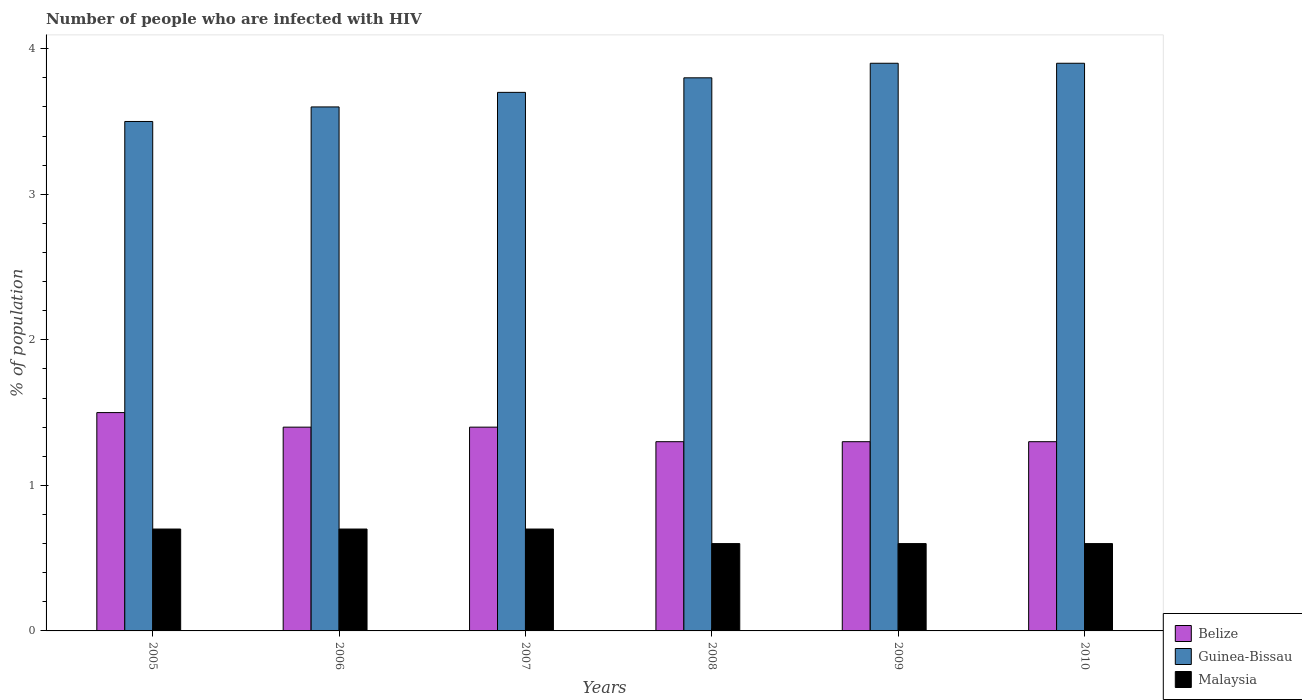How many groups of bars are there?
Provide a short and direct response. 6. Are the number of bars on each tick of the X-axis equal?
Give a very brief answer. Yes. How many bars are there on the 5th tick from the left?
Your response must be concise. 3. In how many cases, is the number of bars for a given year not equal to the number of legend labels?
Give a very brief answer. 0. What is the percentage of HIV infected population in in Belize in 2008?
Give a very brief answer. 1.3. Across all years, what is the maximum percentage of HIV infected population in in Guinea-Bissau?
Keep it short and to the point. 3.9. Across all years, what is the minimum percentage of HIV infected population in in Malaysia?
Your answer should be very brief. 0.6. What is the difference between the percentage of HIV infected population in in Malaysia in 2005 and that in 2007?
Provide a succinct answer. 0. What is the average percentage of HIV infected population in in Malaysia per year?
Provide a succinct answer. 0.65. In how many years, is the percentage of HIV infected population in in Belize greater than 0.4 %?
Offer a terse response. 6. What is the ratio of the percentage of HIV infected population in in Malaysia in 2007 to that in 2008?
Your response must be concise. 1.17. What is the difference between the highest and the lowest percentage of HIV infected population in in Belize?
Provide a succinct answer. 0.2. In how many years, is the percentage of HIV infected population in in Malaysia greater than the average percentage of HIV infected population in in Malaysia taken over all years?
Keep it short and to the point. 3. Is the sum of the percentage of HIV infected population in in Belize in 2006 and 2007 greater than the maximum percentage of HIV infected population in in Malaysia across all years?
Ensure brevity in your answer.  Yes. What does the 2nd bar from the left in 2007 represents?
Your response must be concise. Guinea-Bissau. What does the 1st bar from the right in 2010 represents?
Ensure brevity in your answer.  Malaysia. How many bars are there?
Your answer should be compact. 18. Where does the legend appear in the graph?
Your response must be concise. Bottom right. How are the legend labels stacked?
Keep it short and to the point. Vertical. What is the title of the graph?
Your answer should be very brief. Number of people who are infected with HIV. Does "Finland" appear as one of the legend labels in the graph?
Your answer should be compact. No. What is the label or title of the Y-axis?
Ensure brevity in your answer.  % of population. What is the % of population of Guinea-Bissau in 2006?
Keep it short and to the point. 3.6. What is the % of population of Malaysia in 2007?
Offer a very short reply. 0.7. What is the % of population of Guinea-Bissau in 2008?
Offer a terse response. 3.8. What is the % of population of Malaysia in 2008?
Your answer should be very brief. 0.6. What is the % of population of Belize in 2009?
Your answer should be compact. 1.3. What is the % of population of Guinea-Bissau in 2009?
Offer a very short reply. 3.9. What is the % of population in Belize in 2010?
Make the answer very short. 1.3. Across all years, what is the maximum % of population in Malaysia?
Give a very brief answer. 0.7. Across all years, what is the minimum % of population in Belize?
Your answer should be compact. 1.3. Across all years, what is the minimum % of population in Malaysia?
Offer a very short reply. 0.6. What is the total % of population of Belize in the graph?
Give a very brief answer. 8.2. What is the total % of population in Guinea-Bissau in the graph?
Offer a very short reply. 22.4. What is the difference between the % of population in Belize in 2005 and that in 2006?
Make the answer very short. 0.1. What is the difference between the % of population in Belize in 2005 and that in 2008?
Keep it short and to the point. 0.2. What is the difference between the % of population in Guinea-Bissau in 2005 and that in 2008?
Ensure brevity in your answer.  -0.3. What is the difference between the % of population in Belize in 2005 and that in 2009?
Make the answer very short. 0.2. What is the difference between the % of population in Belize in 2005 and that in 2010?
Your answer should be very brief. 0.2. What is the difference between the % of population of Guinea-Bissau in 2005 and that in 2010?
Your response must be concise. -0.4. What is the difference between the % of population in Malaysia in 2005 and that in 2010?
Offer a very short reply. 0.1. What is the difference between the % of population of Belize in 2006 and that in 2007?
Keep it short and to the point. 0. What is the difference between the % of population of Malaysia in 2006 and that in 2007?
Make the answer very short. 0. What is the difference between the % of population in Guinea-Bissau in 2006 and that in 2008?
Your response must be concise. -0.2. What is the difference between the % of population of Malaysia in 2006 and that in 2008?
Provide a short and direct response. 0.1. What is the difference between the % of population in Guinea-Bissau in 2006 and that in 2009?
Provide a short and direct response. -0.3. What is the difference between the % of population in Malaysia in 2006 and that in 2010?
Your answer should be very brief. 0.1. What is the difference between the % of population of Malaysia in 2007 and that in 2008?
Provide a short and direct response. 0.1. What is the difference between the % of population in Belize in 2007 and that in 2010?
Keep it short and to the point. 0.1. What is the difference between the % of population in Belize in 2008 and that in 2009?
Offer a very short reply. 0. What is the difference between the % of population of Malaysia in 2008 and that in 2009?
Offer a very short reply. 0. What is the difference between the % of population in Belize in 2008 and that in 2010?
Offer a terse response. 0. What is the difference between the % of population of Belize in 2009 and that in 2010?
Provide a short and direct response. 0. What is the difference between the % of population in Guinea-Bissau in 2009 and that in 2010?
Offer a terse response. 0. What is the difference between the % of population of Belize in 2005 and the % of population of Guinea-Bissau in 2006?
Your response must be concise. -2.1. What is the difference between the % of population in Guinea-Bissau in 2005 and the % of population in Malaysia in 2006?
Your answer should be compact. 2.8. What is the difference between the % of population in Belize in 2005 and the % of population in Malaysia in 2007?
Offer a terse response. 0.8. What is the difference between the % of population in Belize in 2005 and the % of population in Malaysia in 2008?
Your response must be concise. 0.9. What is the difference between the % of population of Guinea-Bissau in 2005 and the % of population of Malaysia in 2008?
Provide a succinct answer. 2.9. What is the difference between the % of population in Belize in 2005 and the % of population in Guinea-Bissau in 2009?
Ensure brevity in your answer.  -2.4. What is the difference between the % of population in Belize in 2005 and the % of population in Malaysia in 2009?
Provide a short and direct response. 0.9. What is the difference between the % of population of Belize in 2005 and the % of population of Guinea-Bissau in 2010?
Ensure brevity in your answer.  -2.4. What is the difference between the % of population in Belize in 2006 and the % of population in Guinea-Bissau in 2007?
Your answer should be very brief. -2.3. What is the difference between the % of population in Belize in 2006 and the % of population in Guinea-Bissau in 2008?
Provide a short and direct response. -2.4. What is the difference between the % of population in Belize in 2006 and the % of population in Malaysia in 2008?
Your answer should be very brief. 0.8. What is the difference between the % of population of Belize in 2006 and the % of population of Guinea-Bissau in 2009?
Provide a short and direct response. -2.5. What is the difference between the % of population of Belize in 2007 and the % of population of Malaysia in 2008?
Your answer should be compact. 0.8. What is the difference between the % of population in Guinea-Bissau in 2007 and the % of population in Malaysia in 2009?
Your answer should be very brief. 3.1. What is the difference between the % of population of Belize in 2007 and the % of population of Malaysia in 2010?
Your response must be concise. 0.8. What is the difference between the % of population of Guinea-Bissau in 2008 and the % of population of Malaysia in 2009?
Give a very brief answer. 3.2. What is the difference between the % of population of Belize in 2008 and the % of population of Guinea-Bissau in 2010?
Your answer should be compact. -2.6. What is the difference between the % of population of Belize in 2008 and the % of population of Malaysia in 2010?
Your response must be concise. 0.7. What is the difference between the % of population of Guinea-Bissau in 2008 and the % of population of Malaysia in 2010?
Offer a very short reply. 3.2. What is the difference between the % of population in Belize in 2009 and the % of population in Guinea-Bissau in 2010?
Keep it short and to the point. -2.6. What is the difference between the % of population of Belize in 2009 and the % of population of Malaysia in 2010?
Offer a very short reply. 0.7. What is the difference between the % of population of Guinea-Bissau in 2009 and the % of population of Malaysia in 2010?
Your answer should be very brief. 3.3. What is the average % of population of Belize per year?
Provide a short and direct response. 1.37. What is the average % of population of Guinea-Bissau per year?
Provide a succinct answer. 3.73. What is the average % of population of Malaysia per year?
Offer a very short reply. 0.65. In the year 2005, what is the difference between the % of population in Belize and % of population in Guinea-Bissau?
Ensure brevity in your answer.  -2. In the year 2005, what is the difference between the % of population of Belize and % of population of Malaysia?
Give a very brief answer. 0.8. In the year 2005, what is the difference between the % of population in Guinea-Bissau and % of population in Malaysia?
Make the answer very short. 2.8. In the year 2006, what is the difference between the % of population of Belize and % of population of Guinea-Bissau?
Your answer should be compact. -2.2. In the year 2007, what is the difference between the % of population in Belize and % of population in Malaysia?
Ensure brevity in your answer.  0.7. In the year 2008, what is the difference between the % of population of Belize and % of population of Malaysia?
Ensure brevity in your answer.  0.7. In the year 2009, what is the difference between the % of population in Belize and % of population in Guinea-Bissau?
Your answer should be compact. -2.6. In the year 2010, what is the difference between the % of population in Belize and % of population in Malaysia?
Keep it short and to the point. 0.7. What is the ratio of the % of population in Belize in 2005 to that in 2006?
Your answer should be compact. 1.07. What is the ratio of the % of population in Guinea-Bissau in 2005 to that in 2006?
Keep it short and to the point. 0.97. What is the ratio of the % of population in Belize in 2005 to that in 2007?
Give a very brief answer. 1.07. What is the ratio of the % of population of Guinea-Bissau in 2005 to that in 2007?
Your answer should be very brief. 0.95. What is the ratio of the % of population of Belize in 2005 to that in 2008?
Make the answer very short. 1.15. What is the ratio of the % of population in Guinea-Bissau in 2005 to that in 2008?
Provide a succinct answer. 0.92. What is the ratio of the % of population of Belize in 2005 to that in 2009?
Keep it short and to the point. 1.15. What is the ratio of the % of population in Guinea-Bissau in 2005 to that in 2009?
Give a very brief answer. 0.9. What is the ratio of the % of population of Malaysia in 2005 to that in 2009?
Ensure brevity in your answer.  1.17. What is the ratio of the % of population in Belize in 2005 to that in 2010?
Offer a terse response. 1.15. What is the ratio of the % of population of Guinea-Bissau in 2005 to that in 2010?
Your response must be concise. 0.9. What is the ratio of the % of population in Guinea-Bissau in 2006 to that in 2007?
Offer a terse response. 0.97. What is the ratio of the % of population in Malaysia in 2006 to that in 2007?
Give a very brief answer. 1. What is the ratio of the % of population of Belize in 2006 to that in 2010?
Ensure brevity in your answer.  1.08. What is the ratio of the % of population in Malaysia in 2006 to that in 2010?
Offer a terse response. 1.17. What is the ratio of the % of population in Guinea-Bissau in 2007 to that in 2008?
Ensure brevity in your answer.  0.97. What is the ratio of the % of population of Belize in 2007 to that in 2009?
Provide a succinct answer. 1.08. What is the ratio of the % of population of Guinea-Bissau in 2007 to that in 2009?
Keep it short and to the point. 0.95. What is the ratio of the % of population in Malaysia in 2007 to that in 2009?
Make the answer very short. 1.17. What is the ratio of the % of population of Guinea-Bissau in 2007 to that in 2010?
Ensure brevity in your answer.  0.95. What is the ratio of the % of population in Belize in 2008 to that in 2009?
Keep it short and to the point. 1. What is the ratio of the % of population in Guinea-Bissau in 2008 to that in 2009?
Your answer should be very brief. 0.97. What is the ratio of the % of population in Guinea-Bissau in 2008 to that in 2010?
Ensure brevity in your answer.  0.97. What is the ratio of the % of population in Malaysia in 2008 to that in 2010?
Provide a short and direct response. 1. What is the difference between the highest and the second highest % of population in Malaysia?
Ensure brevity in your answer.  0. What is the difference between the highest and the lowest % of population in Belize?
Provide a succinct answer. 0.2. What is the difference between the highest and the lowest % of population of Guinea-Bissau?
Your answer should be very brief. 0.4. What is the difference between the highest and the lowest % of population of Malaysia?
Make the answer very short. 0.1. 